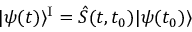Convert formula to latex. <formula><loc_0><loc_0><loc_500><loc_500>| \psi ( t ) \rangle ^ { I } = \hat { S } ( t , t _ { 0 } ) | \psi ( t _ { 0 } ) \rangle</formula> 